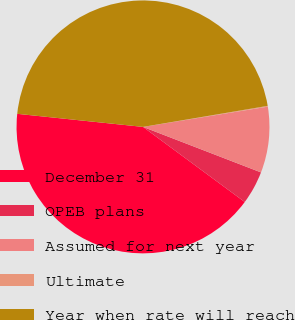<chart> <loc_0><loc_0><loc_500><loc_500><pie_chart><fcel>December 31<fcel>OPEB plans<fcel>Assumed for next year<fcel>Ultimate<fcel>Year when rate will reach<nl><fcel>41.53%<fcel>4.26%<fcel>8.42%<fcel>0.1%<fcel>45.69%<nl></chart> 